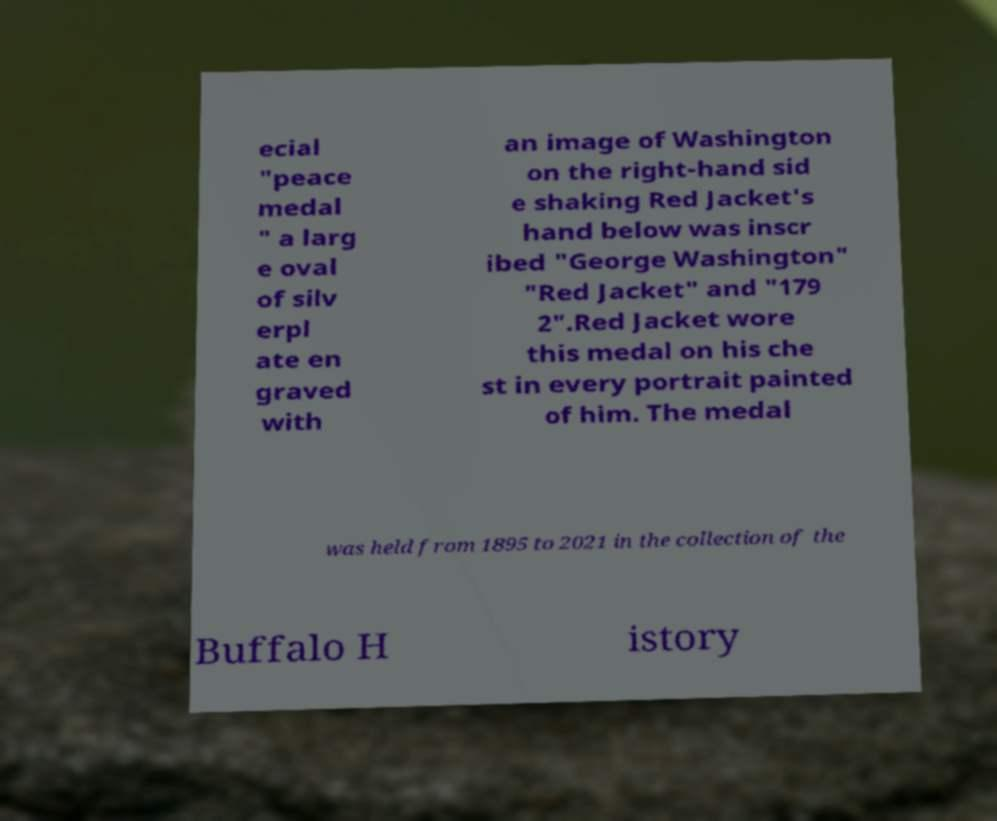Could you extract and type out the text from this image? ecial "peace medal " a larg e oval of silv erpl ate en graved with an image of Washington on the right-hand sid e shaking Red Jacket's hand below was inscr ibed "George Washington" "Red Jacket" and "179 2".Red Jacket wore this medal on his che st in every portrait painted of him. The medal was held from 1895 to 2021 in the collection of the Buffalo H istory 